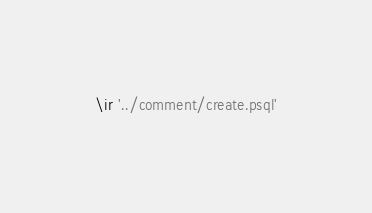Convert code to text. <code><loc_0><loc_0><loc_500><loc_500><_SQL_>\ir '../comment/create.psql'
</code> 